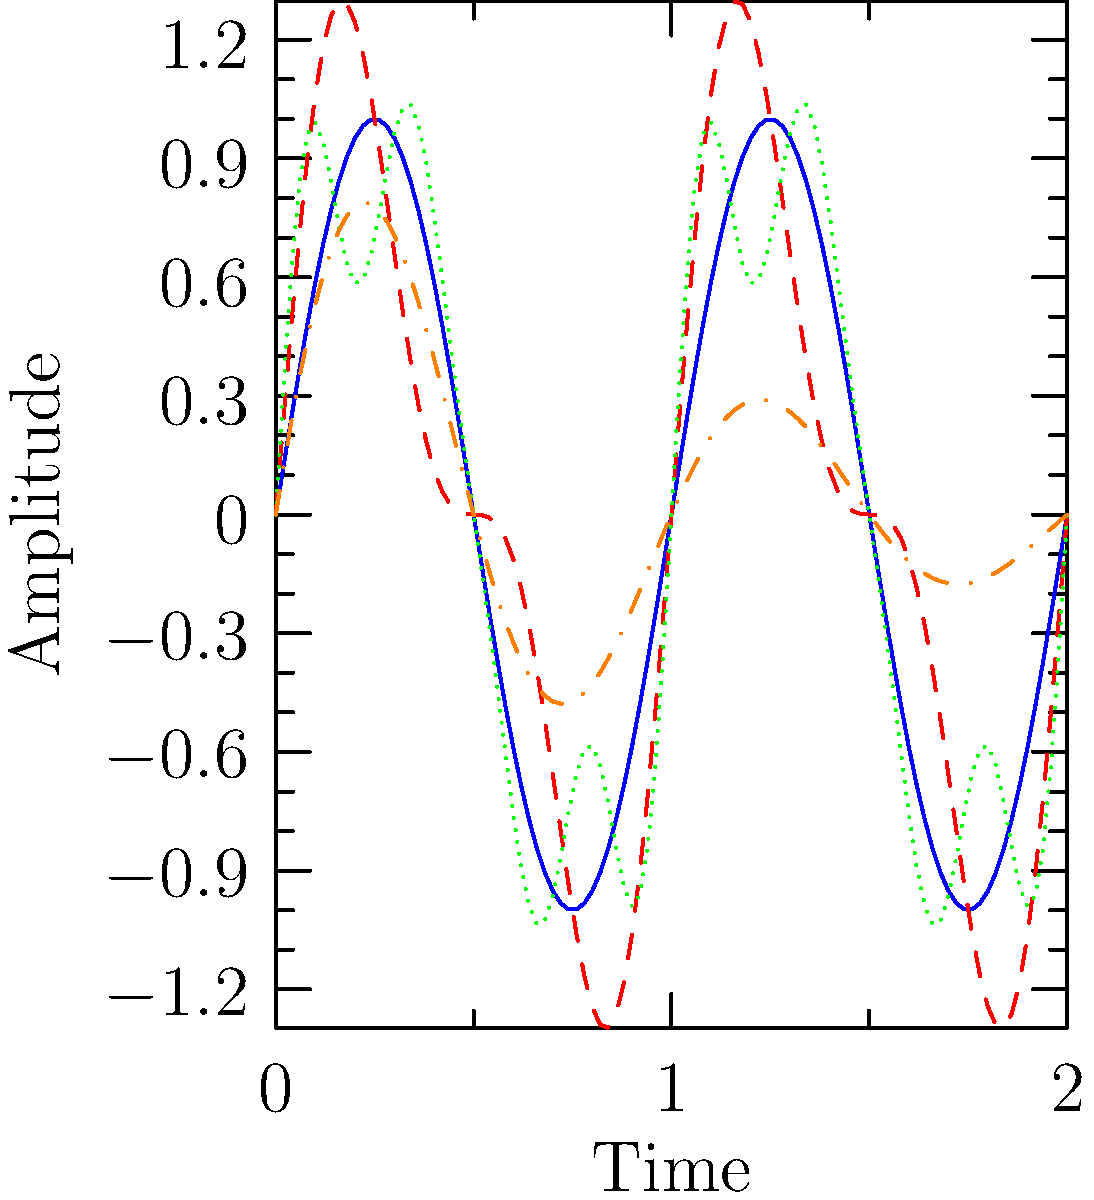Identify which waveform pattern corresponds to a decaying radio signal typically observed from a pulsar. To identify the waveform pattern corresponding to a decaying radio signal from a pulsar, we need to analyze the characteristics of each curve:

1. Type A (blue, solid): This is a simple sine wave, representing a continuous, uniform radio signal. It doesn't show any decay.

2. Type B (red, dashed): This waveform shows a more complex pattern with higher harmonics, but maintains a constant amplitude over time.

3. Type C (green, dotted): Similar to Type B, this waveform has even more harmonics, creating a more complex pattern. However, it also maintains a constant amplitude.

4. Type D (orange, dash-dotted): This waveform starts with a high amplitude and gradually decreases over time while maintaining its oscillatory nature. This pattern is characteristic of a decaying signal.

Pulsars are rapidly rotating neutron stars that emit beams of electromagnetic radiation. As these beams sweep past Earth, we observe pulses of radiation. Due to various factors such as magnetic field decay, plasma effects, and energy loss, the intensity of these pulses typically decays over time.

The Type D waveform (orange, dash-dotted) shows an exponentially decaying sine wave, which is mathematically represented as $A(t) = A_0 e^{-t/\tau} \sin(2\pi f t)$, where $A_0$ is the initial amplitude, $\tau$ is the decay time constant, and $f$ is the frequency. This pattern closely matches the expected behavior of a pulsar's radio signal as observed from Earth.
Answer: Type D 